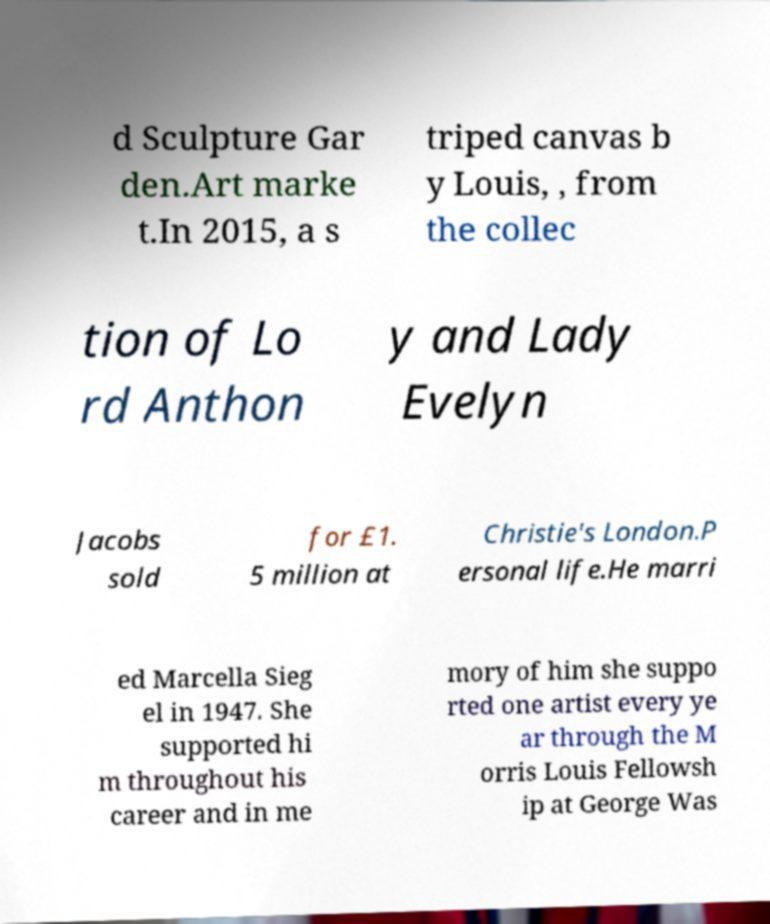Please read and relay the text visible in this image. What does it say? d Sculpture Gar den.Art marke t.In 2015, a s triped canvas b y Louis, , from the collec tion of Lo rd Anthon y and Lady Evelyn Jacobs sold for £1. 5 million at Christie's London.P ersonal life.He marri ed Marcella Sieg el in 1947. She supported hi m throughout his career and in me mory of him she suppo rted one artist every ye ar through the M orris Louis Fellowsh ip at George Was 